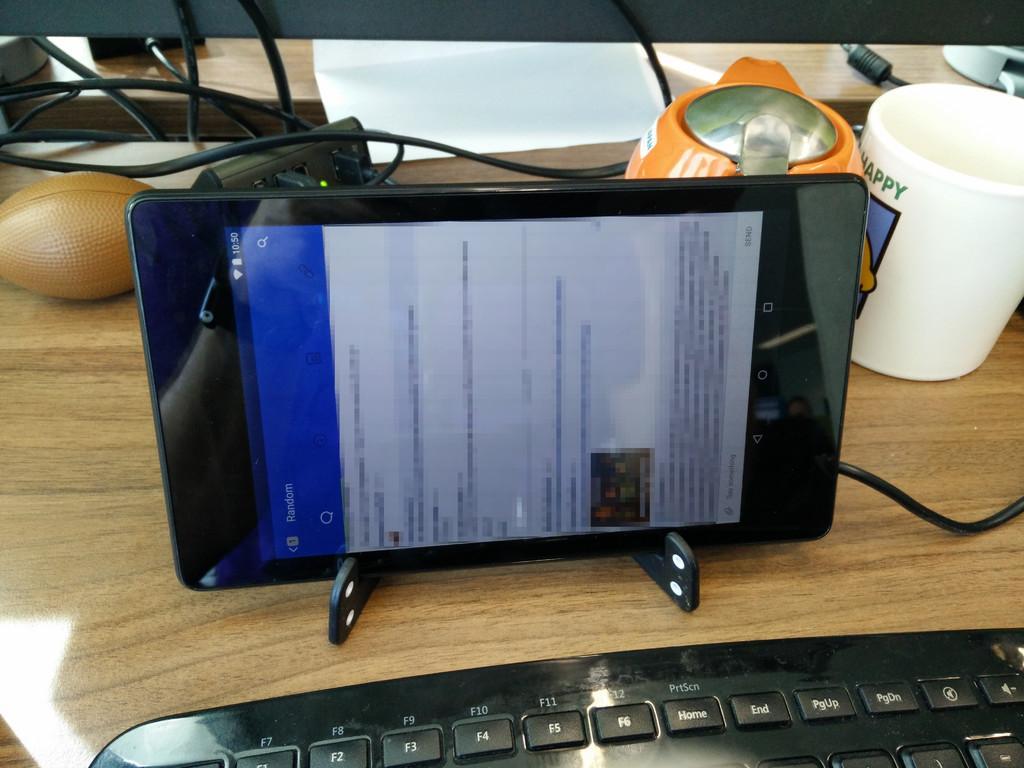Could you give a brief overview of what you see in this image? In this image we can see a gadget, here is the screen, at behind here is the white color cup on the table, here is the wire, here is the keyboard on it. 